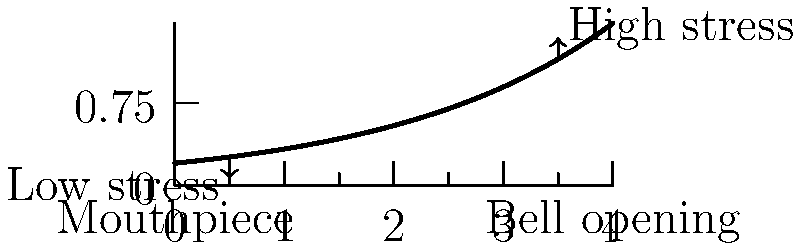As a trumpet player, you're likely aware of the physical demands placed on your instrument during performance. Consider the stress distribution in a trumpet bell under playing conditions. Which region of the bell experiences the highest stress, and what factors contribute to this stress concentration? To understand the stress distribution in a trumpet bell, let's break it down step-by-step:

1. Geometry: The trumpet bell has an exponential flare, with the diameter increasing rapidly towards the opening.

2. Playing conditions: When a trumpet is played, air pressure waves travel through the instrument.

3. Stress distribution:
   a) Near the mouthpiece: The bell diameter is smaller, resulting in lower stress.
   b) Towards the bell opening: The diameter increases rapidly, leading to higher stress.

4. Factors contributing to stress concentration:
   a) Pressure waves: As sound waves propagate, they create alternating regions of compression and rarefaction.
   b) Bell curvature: The rapid change in curvature near the bell opening causes stress concentration.
   c) Material properties: The brass alloy used in trumpets has specific elastic properties that affect stress distribution.

5. Highest stress region: The area near the bell opening experiences the highest stress due to:
   a) Larger diameter: More surface area exposed to pressure fluctuations.
   b) Rapid curvature change: Sharp geometric transitions concentrate stress.
   c) Acoustic wave behavior: Standing waves form with maximum amplitude near the bell opening.

6. Mathematical representation: The stress ($\sigma$) in a thin-walled pressure vessel (approximating the trumpet bell) can be expressed as:

   $$\sigma = \frac{pr}{2t}$$

   Where $p$ is internal pressure, $r$ is local radius, and $t$ is wall thickness.

7. As $r$ increases towards the bell opening, $\sigma$ increases proportionally, assuming constant wall thickness and pressure.

In summary, the region near the bell opening experiences the highest stress due to its larger diameter, rapid curvature change, and the behavior of acoustic waves within the instrument.
Answer: Bell opening region; larger diameter, rapid curvature change, acoustic wave behavior. 